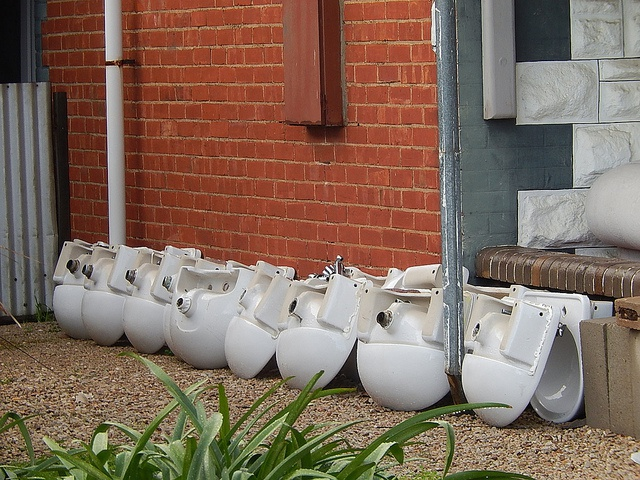Describe the objects in this image and their specific colors. I can see toilet in black, darkgray, lightgray, and gray tones, sink in black, lightgray, and darkgray tones, toilet in black, lightgray, darkgray, and gray tones, sink in black, lightgray, darkgray, and gray tones, and sink in black, darkgray, lightgray, and gray tones in this image. 